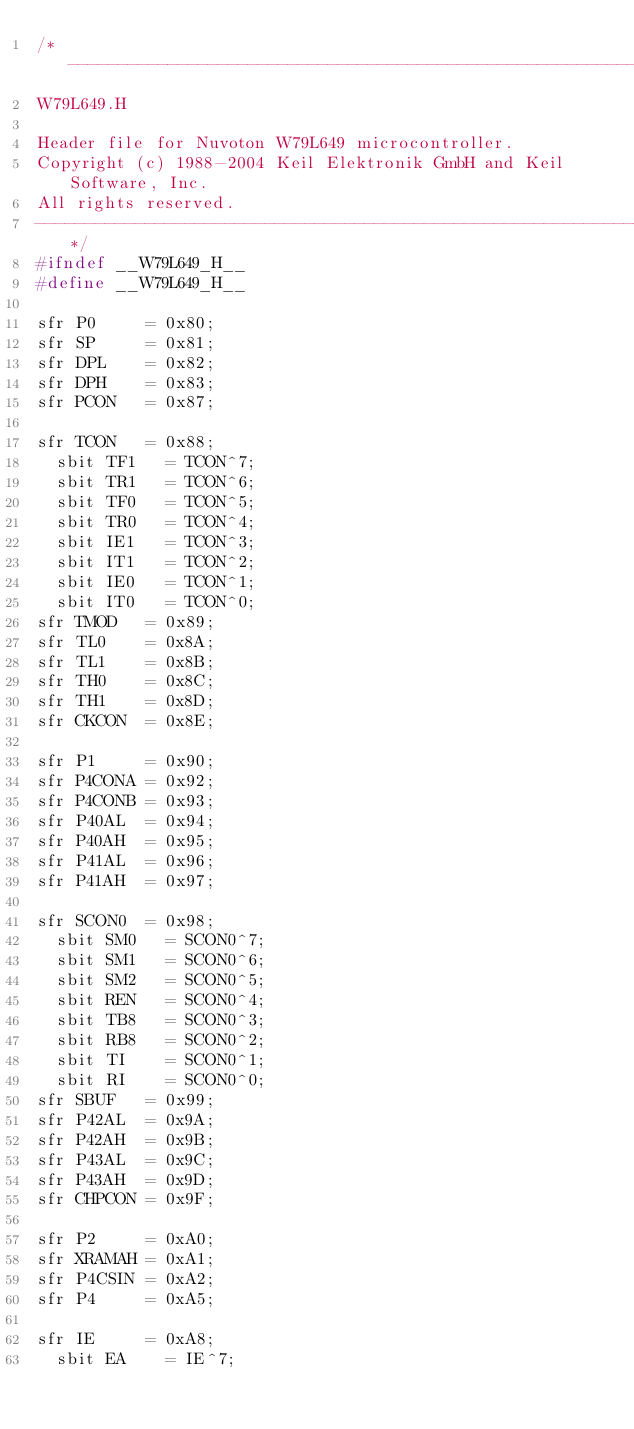Convert code to text. <code><loc_0><loc_0><loc_500><loc_500><_C_>/*--------------------------------------------------------------------------
W79L649.H

Header file for Nuvoton W79L649 microcontroller.
Copyright (c) 1988-2004 Keil Elektronik GmbH and Keil Software, Inc.
All rights reserved.
--------------------------------------------------------------------------*/
#ifndef __W79L649_H__
#define __W79L649_H__

sfr P0     = 0x80;
sfr SP     = 0x81;
sfr DPL	   = 0x82;
sfr DPH    = 0x83;
sfr PCON   = 0x87;

sfr TCON   = 0x88;
  sbit TF1   = TCON^7;
  sbit TR1   = TCON^6;
  sbit TF0   = TCON^5;
  sbit TR0   = TCON^4;
  sbit IE1   = TCON^3;
  sbit IT1   = TCON^2;
  sbit IE0   = TCON^1;
  sbit IT0   = TCON^0;
sfr TMOD   = 0x89;
sfr TL0    = 0x8A;
sfr	TL1    = 0x8B;
sfr TH0    = 0x8C;
sfr TH1    = 0x8D;
sfr CKCON  = 0x8E;

sfr P1     = 0x90;
sfr P4CONA = 0x92;
sfr P4CONB = 0x93;
sfr P40AL  = 0x94;
sfr P40AH  = 0x95;
sfr P41AL  = 0x96;
sfr P41AH  = 0x97;

sfr SCON0  = 0x98;
  sbit SM0   = SCON0^7;
  sbit SM1   = SCON0^6;
  sbit SM2   = SCON0^5;
  sbit REN   = SCON0^4;
  sbit TB8   = SCON0^3;
  sbit RB8   = SCON0^2;
  sbit TI    = SCON0^1;
  sbit RI    = SCON0^0;
sfr SBUF   = 0x99;
sfr P42AL  = 0x9A;
sfr P42AH  = 0x9B;
sfr P43AL  = 0x9C;
sfr P43AH  = 0x9D;
sfr CHPCON = 0x9F;

sfr P2     = 0xA0;
sfr XRAMAH = 0xA1;
sfr P4CSIN = 0xA2;
sfr P4     = 0xA5;

sfr IE     = 0xA8;
  sbit EA    = IE^7;</code> 